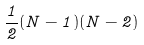Convert formula to latex. <formula><loc_0><loc_0><loc_500><loc_500>\frac { 1 } { 2 } ( N - 1 ) ( N - 2 )</formula> 